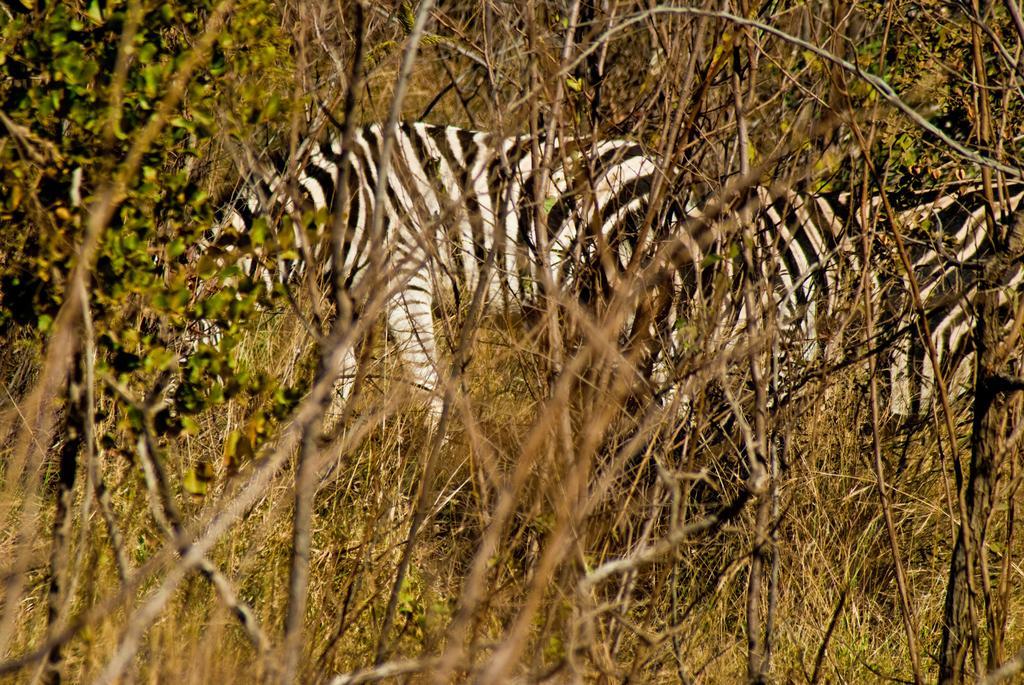Can you describe this image briefly? In this picture we can see few zebras are standing, in the background there are some trees, we can see some plants at the bottom. 